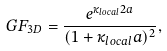Convert formula to latex. <formula><loc_0><loc_0><loc_500><loc_500>G F _ { 3 D } = \frac { e ^ { \kappa _ { l o c a l } 2 a } } { ( 1 + \kappa _ { l o c a l } a ) ^ { 2 } } ,</formula> 